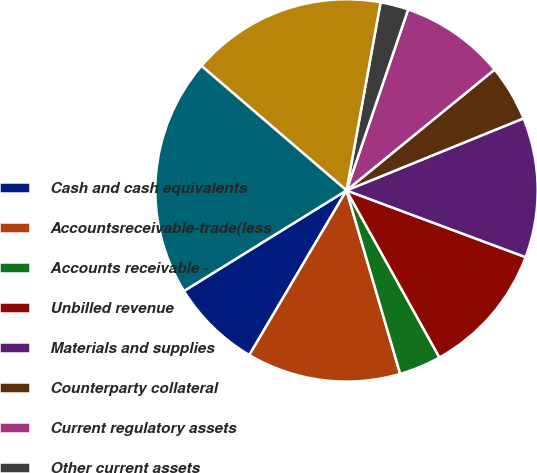Convert chart. <chart><loc_0><loc_0><loc_500><loc_500><pie_chart><fcel>Cash and cash equivalents<fcel>Accountsreceivable-trade(less<fcel>Accounts receivable -<fcel>Unbilled revenue<fcel>Materials and supplies<fcel>Counterparty collateral<fcel>Current regulatory assets<fcel>Other current assets<fcel>Total current assets<fcel>Property and Plant Net<nl><fcel>7.69%<fcel>13.02%<fcel>3.55%<fcel>11.24%<fcel>11.83%<fcel>4.74%<fcel>8.88%<fcel>2.37%<fcel>16.56%<fcel>20.11%<nl></chart> 